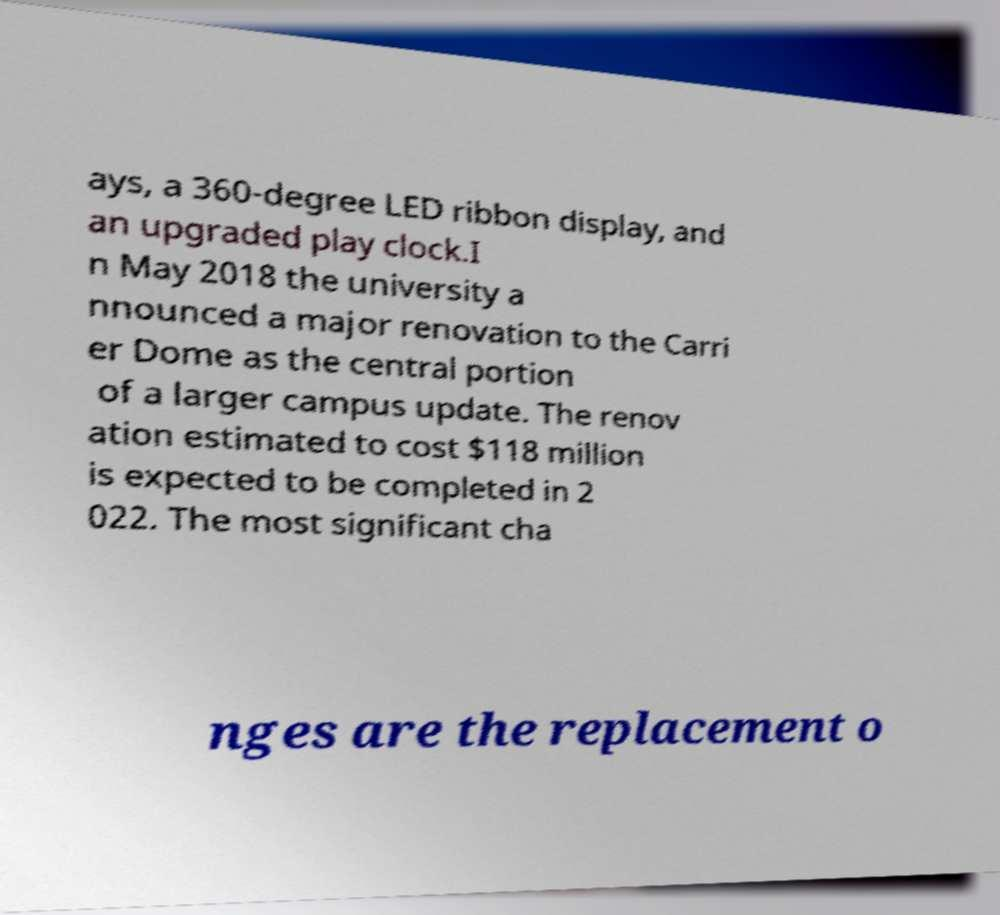Can you read and provide the text displayed in the image?This photo seems to have some interesting text. Can you extract and type it out for me? ays, a 360-degree LED ribbon display, and an upgraded play clock.I n May 2018 the university a nnounced a major renovation to the Carri er Dome as the central portion of a larger campus update. The renov ation estimated to cost $118 million is expected to be completed in 2 022. The most significant cha nges are the replacement o 